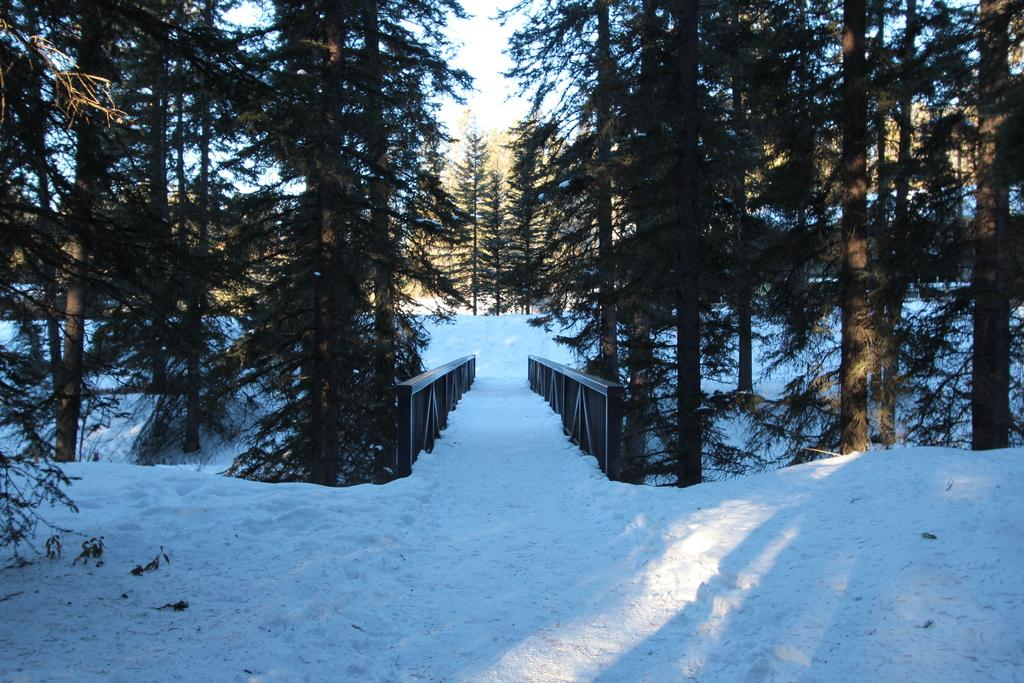What type of weather condition is depicted at the bottom of the image? There is snow at the bottom of the image. What type of natural environment can be seen in the background of the image? There are trees in the background of the image. What is visible at the top of the image? The sky is visible at the top of the image. What type of discovery was made by the wind in the image? There is no mention of a discovery or wind in the image. 